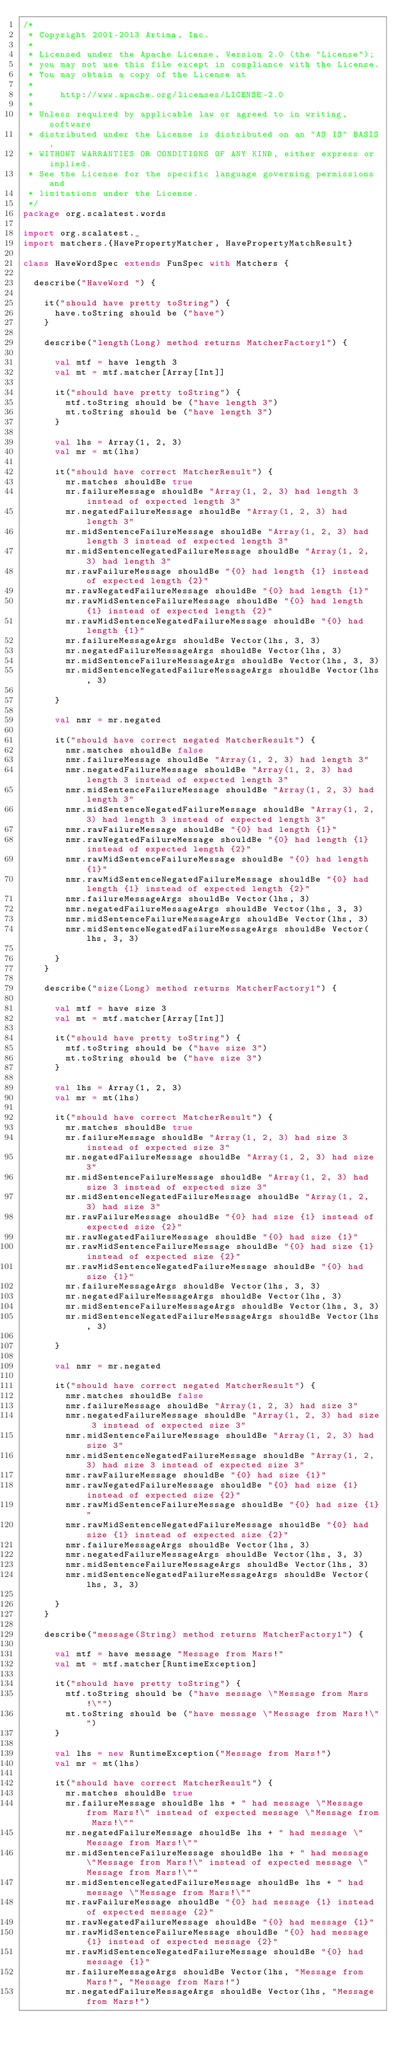Convert code to text. <code><loc_0><loc_0><loc_500><loc_500><_Scala_>/*
 * Copyright 2001-2013 Artima, Inc.
 *
 * Licensed under the Apache License, Version 2.0 (the "License");
 * you may not use this file except in compliance with the License.
 * You may obtain a copy of the License at
 *
 *     http://www.apache.org/licenses/LICENSE-2.0
 *
 * Unless required by applicable law or agreed to in writing, software
 * distributed under the License is distributed on an "AS IS" BASIS,
 * WITHOUT WARRANTIES OR CONDITIONS OF ANY KIND, either express or implied.
 * See the License for the specific language governing permissions and
 * limitations under the License.
 */
package org.scalatest.words

import org.scalatest._
import matchers.{HavePropertyMatcher, HavePropertyMatchResult}

class HaveWordSpec extends FunSpec with Matchers {
  
  describe("HaveWord ") {
    
    it("should have pretty toString") {
      have.toString should be ("have")
    }
    
    describe("length(Long) method returns MatcherFactory1") {
      
      val mtf = have length 3
      val mt = mtf.matcher[Array[Int]]
      
      it("should have pretty toString") {
        mtf.toString should be ("have length 3")
        mt.toString should be ("have length 3")
      }
      
      val lhs = Array(1, 2, 3)
      val mr = mt(lhs)
      
      it("should have correct MatcherResult") {
        mr.matches shouldBe true
        mr.failureMessage shouldBe "Array(1, 2, 3) had length 3 instead of expected length 3"
        mr.negatedFailureMessage shouldBe "Array(1, 2, 3) had length 3"
        mr.midSentenceFailureMessage shouldBe "Array(1, 2, 3) had length 3 instead of expected length 3"
        mr.midSentenceNegatedFailureMessage shouldBe "Array(1, 2, 3) had length 3"
        mr.rawFailureMessage shouldBe "{0} had length {1} instead of expected length {2}"
        mr.rawNegatedFailureMessage shouldBe "{0} had length {1}"
        mr.rawMidSentenceFailureMessage shouldBe "{0} had length {1} instead of expected length {2}"
        mr.rawMidSentenceNegatedFailureMessage shouldBe "{0} had length {1}"
        mr.failureMessageArgs shouldBe Vector(lhs, 3, 3)
        mr.negatedFailureMessageArgs shouldBe Vector(lhs, 3)
        mr.midSentenceFailureMessageArgs shouldBe Vector(lhs, 3, 3)
        mr.midSentenceNegatedFailureMessageArgs shouldBe Vector(lhs, 3)

      }
      
      val nmr = mr.negated
      
      it("should have correct negated MatcherResult") {
        nmr.matches shouldBe false
        nmr.failureMessage shouldBe "Array(1, 2, 3) had length 3"
        nmr.negatedFailureMessage shouldBe "Array(1, 2, 3) had length 3 instead of expected length 3"
        nmr.midSentenceFailureMessage shouldBe "Array(1, 2, 3) had length 3"
        nmr.midSentenceNegatedFailureMessage shouldBe "Array(1, 2, 3) had length 3 instead of expected length 3"
        nmr.rawFailureMessage shouldBe "{0} had length {1}"
        nmr.rawNegatedFailureMessage shouldBe "{0} had length {1} instead of expected length {2}"
        nmr.rawMidSentenceFailureMessage shouldBe "{0} had length {1}"
        nmr.rawMidSentenceNegatedFailureMessage shouldBe "{0} had length {1} instead of expected length {2}"
        nmr.failureMessageArgs shouldBe Vector(lhs, 3)
        nmr.negatedFailureMessageArgs shouldBe Vector(lhs, 3, 3)
        nmr.midSentenceFailureMessageArgs shouldBe Vector(lhs, 3)
        nmr.midSentenceNegatedFailureMessageArgs shouldBe Vector(lhs, 3, 3)

      }
    }
    
    describe("size(Long) method returns MatcherFactory1") {
      
      val mtf = have size 3
      val mt = mtf.matcher[Array[Int]]
      
      it("should have pretty toString") {
        mtf.toString should be ("have size 3")
        mt.toString should be ("have size 3")
      }
      
      val lhs = Array(1, 2, 3)
      val mr = mt(lhs)
      
      it("should have correct MatcherResult") {
        mr.matches shouldBe true
        mr.failureMessage shouldBe "Array(1, 2, 3) had size 3 instead of expected size 3"
        mr.negatedFailureMessage shouldBe "Array(1, 2, 3) had size 3"
        mr.midSentenceFailureMessage shouldBe "Array(1, 2, 3) had size 3 instead of expected size 3"
        mr.midSentenceNegatedFailureMessage shouldBe "Array(1, 2, 3) had size 3"
        mr.rawFailureMessage shouldBe "{0} had size {1} instead of expected size {2}"
        mr.rawNegatedFailureMessage shouldBe "{0} had size {1}"
        mr.rawMidSentenceFailureMessage shouldBe "{0} had size {1} instead of expected size {2}"
        mr.rawMidSentenceNegatedFailureMessage shouldBe "{0} had size {1}"
        mr.failureMessageArgs shouldBe Vector(lhs, 3, 3)
        mr.negatedFailureMessageArgs shouldBe Vector(lhs, 3)
        mr.midSentenceFailureMessageArgs shouldBe Vector(lhs, 3, 3)
        mr.midSentenceNegatedFailureMessageArgs shouldBe Vector(lhs, 3)

      }
      
      val nmr = mr.negated
      
      it("should have correct negated MatcherResult") {
        nmr.matches shouldBe false
        nmr.failureMessage shouldBe "Array(1, 2, 3) had size 3"
        nmr.negatedFailureMessage shouldBe "Array(1, 2, 3) had size 3 instead of expected size 3"
        nmr.midSentenceFailureMessage shouldBe "Array(1, 2, 3) had size 3"
        nmr.midSentenceNegatedFailureMessage shouldBe "Array(1, 2, 3) had size 3 instead of expected size 3"
        nmr.rawFailureMessage shouldBe "{0} had size {1}"
        nmr.rawNegatedFailureMessage shouldBe "{0} had size {1} instead of expected size {2}"
        nmr.rawMidSentenceFailureMessage shouldBe "{0} had size {1}"
        nmr.rawMidSentenceNegatedFailureMessage shouldBe "{0} had size {1} instead of expected size {2}"
        nmr.failureMessageArgs shouldBe Vector(lhs, 3)
        nmr.negatedFailureMessageArgs shouldBe Vector(lhs, 3, 3)
        nmr.midSentenceFailureMessageArgs shouldBe Vector(lhs, 3)
        nmr.midSentenceNegatedFailureMessageArgs shouldBe Vector(lhs, 3, 3)

      }
    }
    
    describe("message(String) method returns MatcherFactory1") {
      
      val mtf = have message "Message from Mars!"
      val mt = mtf.matcher[RuntimeException]
      
      it("should have pretty toString") {
        mtf.toString should be ("have message \"Message from Mars!\"")
        mt.toString should be ("have message \"Message from Mars!\"")
      }
      
      val lhs = new RuntimeException("Message from Mars!")
      val mr = mt(lhs)
      
      it("should have correct MatcherResult") {
        mr.matches shouldBe true
        mr.failureMessage shouldBe lhs + " had message \"Message from Mars!\" instead of expected message \"Message from Mars!\""
        mr.negatedFailureMessage shouldBe lhs + " had message \"Message from Mars!\""
        mr.midSentenceFailureMessage shouldBe lhs + " had message \"Message from Mars!\" instead of expected message \"Message from Mars!\""
        mr.midSentenceNegatedFailureMessage shouldBe lhs + " had message \"Message from Mars!\""
        mr.rawFailureMessage shouldBe "{0} had message {1} instead of expected message {2}"
        mr.rawNegatedFailureMessage shouldBe "{0} had message {1}"
        mr.rawMidSentenceFailureMessage shouldBe "{0} had message {1} instead of expected message {2}"
        mr.rawMidSentenceNegatedFailureMessage shouldBe "{0} had message {1}"
        mr.failureMessageArgs shouldBe Vector(lhs, "Message from Mars!", "Message from Mars!")
        mr.negatedFailureMessageArgs shouldBe Vector(lhs, "Message from Mars!")</code> 